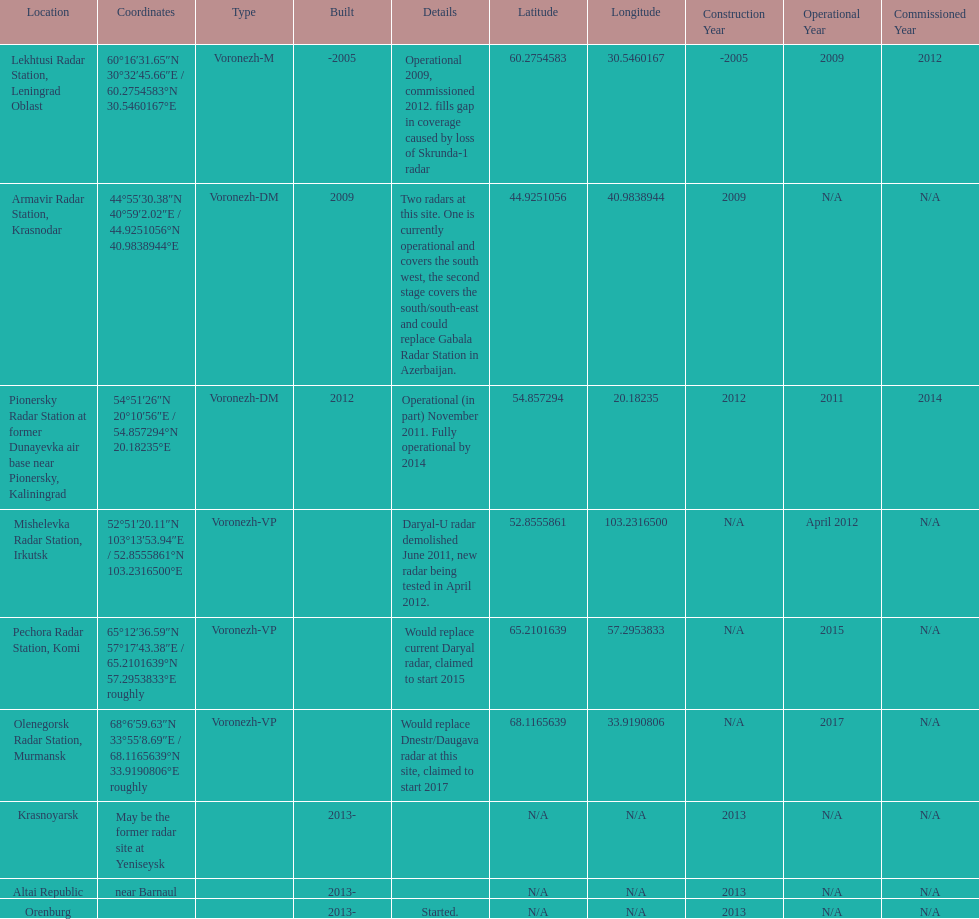What year built is at the top? -2005. I'm looking to parse the entire table for insights. Could you assist me with that? {'header': ['Location', 'Coordinates', 'Type', 'Built', 'Details', 'Latitude', 'Longitude', 'Construction Year', 'Operational Year', 'Commissioned Year'], 'rows': [['Lekhtusi Radar Station, Leningrad Oblast', '60°16′31.65″N 30°32′45.66″E\ufeff / \ufeff60.2754583°N 30.5460167°E', 'Voronezh-M', '-2005', 'Operational 2009, commissioned 2012. fills gap in coverage caused by loss of Skrunda-1 radar', '60.2754583', '30.5460167', '-2005', '2009', '2012'], ['Armavir Radar Station, Krasnodar', '44°55′30.38″N 40°59′2.02″E\ufeff / \ufeff44.9251056°N 40.9838944°E', 'Voronezh-DM', '2009', 'Two radars at this site. One is currently operational and covers the south west, the second stage covers the south/south-east and could replace Gabala Radar Station in Azerbaijan.', '44.9251056', '40.9838944', '2009', 'N/A', 'N/A'], ['Pionersky Radar Station at former Dunayevka air base near Pionersky, Kaliningrad', '54°51′26″N 20°10′56″E\ufeff / \ufeff54.857294°N 20.18235°E', 'Voronezh-DM', '2012', 'Operational (in part) November 2011. Fully operational by 2014', '54.857294', '20.18235', '2012', '2011', '2014'], ['Mishelevka Radar Station, Irkutsk', '52°51′20.11″N 103°13′53.94″E\ufeff / \ufeff52.8555861°N 103.2316500°E', 'Voronezh-VP', '', 'Daryal-U radar demolished June 2011, new radar being tested in April 2012.', '52.8555861', '103.2316500', 'N/A', 'April 2012', 'N/A'], ['Pechora Radar Station, Komi', '65°12′36.59″N 57°17′43.38″E\ufeff / \ufeff65.2101639°N 57.2953833°E roughly', 'Voronezh-VP', '', 'Would replace current Daryal radar, claimed to start 2015', '65.2101639', '57.2953833', 'N/A', '2015', 'N/A'], ['Olenegorsk Radar Station, Murmansk', '68°6′59.63″N 33°55′8.69″E\ufeff / \ufeff68.1165639°N 33.9190806°E roughly', 'Voronezh-VP', '', 'Would replace Dnestr/Daugava radar at this site, claimed to start 2017', '68.1165639', '33.9190806', 'N/A', '2017', 'N/A'], ['Krasnoyarsk', 'May be the former radar site at Yeniseysk', '', '2013-', '', 'N/A', 'N/A', '2013', 'N/A', 'N/A'], ['Altai Republic', 'near Barnaul', '', '2013-', '', 'N/A', 'N/A', '2013', 'N/A', 'N/A'], ['Orenburg', '', '', '2013-', 'Started.', 'N/A', 'N/A', '2013', 'N/A', 'N/A']]} 